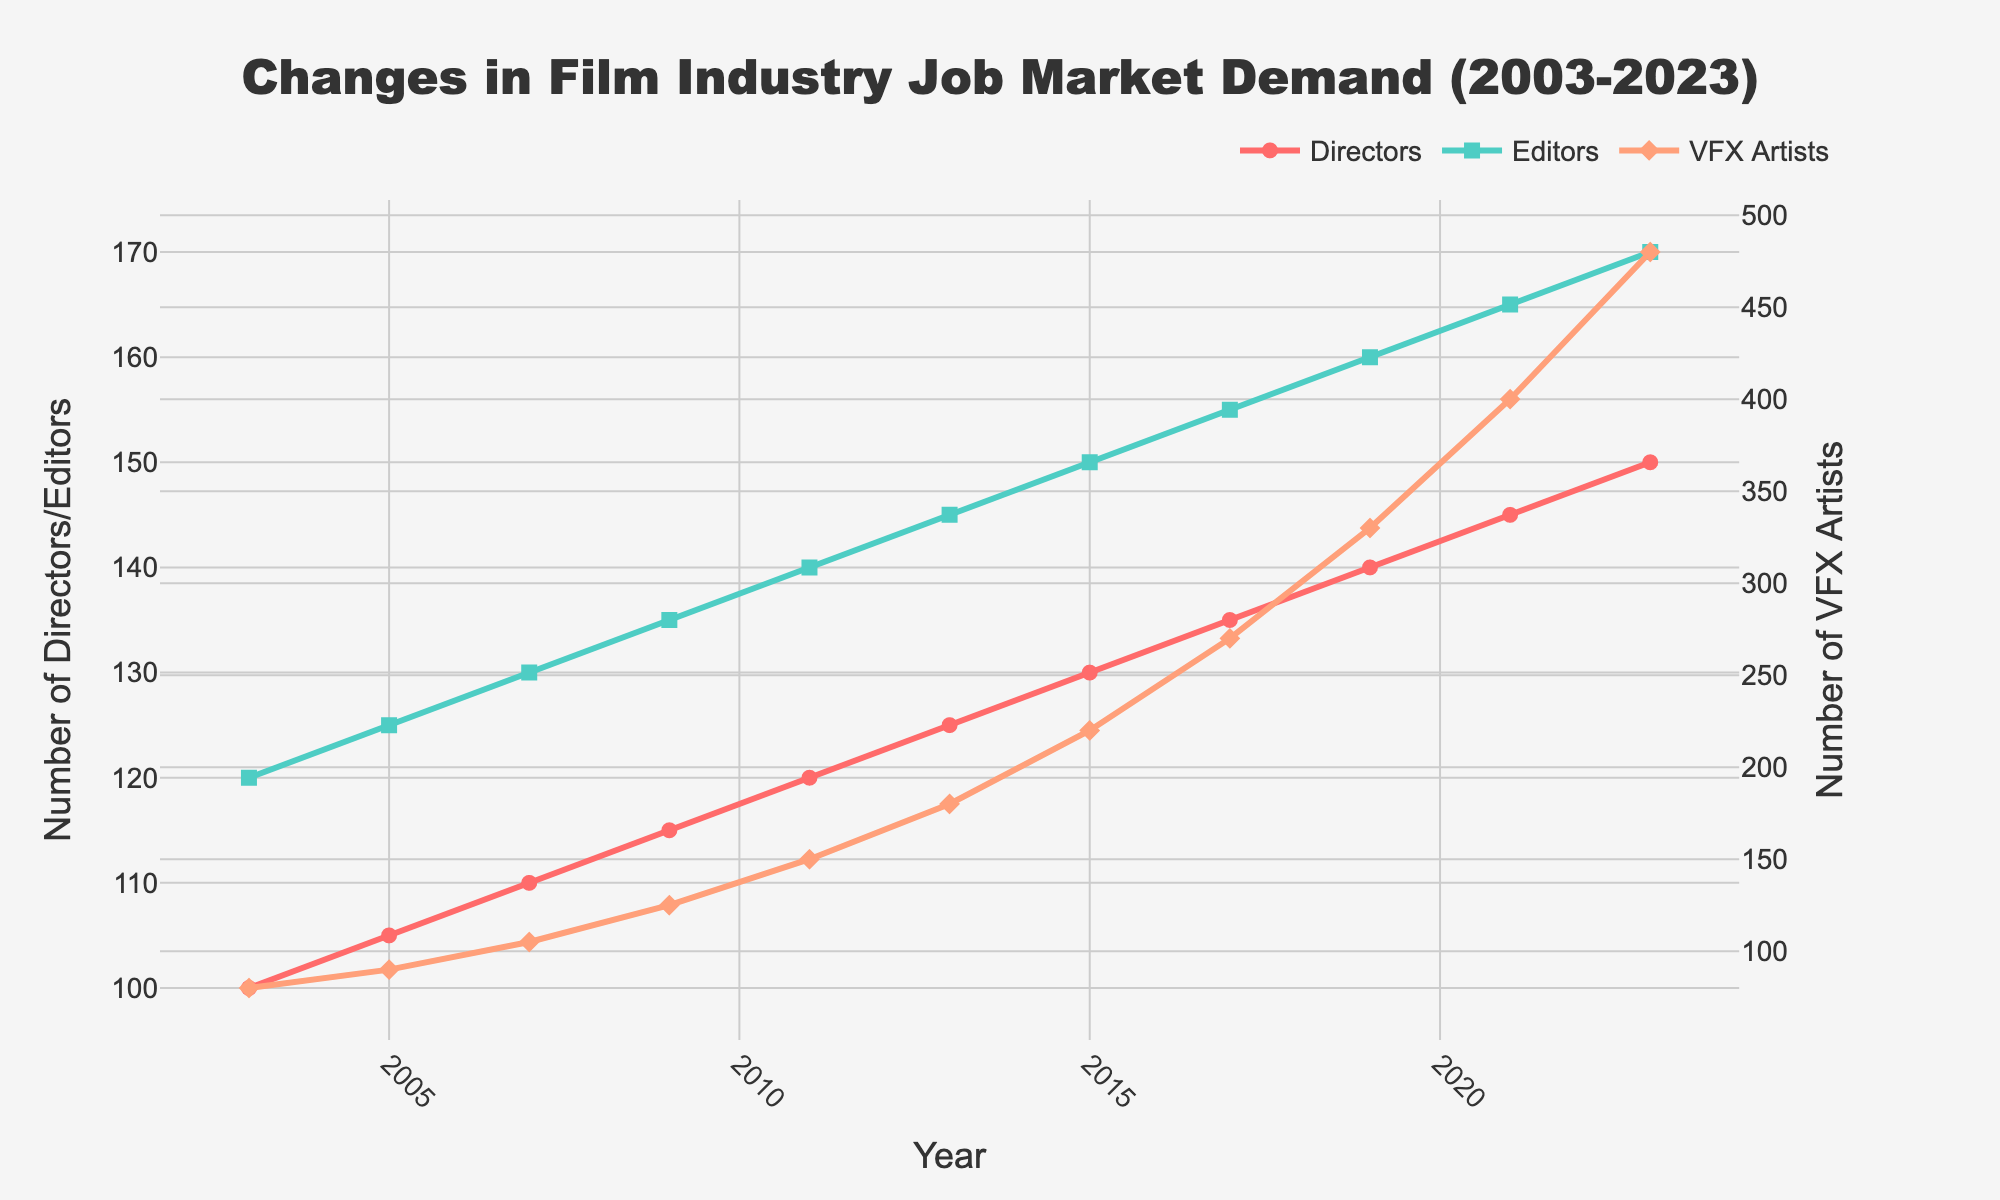What is the demand trend for VFX Artists from 2003 to 2023? The demand for VFX Artists shows an increasing trend from 2003 to 2023, with a significant rise around 2013, accelerating sharply towards 2023.
Answer: Increasing How does the demand for Editors in 2023 compare to the demand for Directors in the same year? In 2023, the demand for Editors is the same as for Directors, both showing a value of 170.
Answer: Equal In which year does the demand for Directors first reach 125? By examining the line for Directors, the demand first reaches 125 in 2013.
Answer: 2013 How much did the demand for VFX Artists increase between 2003 and 2023? The demand for VFX Artists in 2003 was 80 and increased to 480 in 2023. Therefore, the increase is 480 - 80 = 400.
Answer: 400 Compare the overall demand for Directors and Editors from 2003 to 2023. Which role has a higher demand trend? Both the demand for Directors and Editors shows an increasing trend from 2003 to 2023, but the Editors' demand consistently remains higher than the Directors' demand in each year.
Answer: Editors What is the average demand for VFX Artists over the years provided? The total demand values for VFX Artists are: 80, 90, 105, 125, 150, 180, 220, 270, 330, 400, 480. The average is (80 + 90 + 105 + 125 + 150 + 180 + 220 + 270 + 330 + 400 + 480) / 11 = 247.27.
Answer: 247.27 Identify the year with the highest demand for Editors and give the value. The highest demand for Editors can be seen in 2023, where it reaches 170.
Answer: 2023, 170 If we consider the proportional change, which role sees the highest proportional increase in demand from 2003 to 2023? For Directors: (150-100)/100 = 0.5 or 50%, Editors: (170-120)/120 = 0.4167 or 41.67%, VFX Artists: (480-80)/80 = 5 or 500%. VFX Artists have the highest proportional increase.
Answer: VFX Artists Which role showed the least amount of variation in demand from 2003 to 2023? By comparing the variation from the lines' steepness and fluctuation, Directors show the least amount of variation with a more gradual increase compared to Editors and VFX Artists.
Answer: Directors 